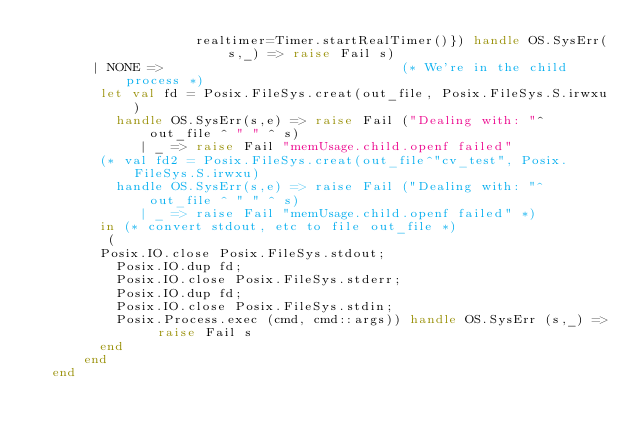<code> <loc_0><loc_0><loc_500><loc_500><_SML_>					realtimer=Timer.startRealTimer()}) handle OS.SysErr(s,_) => raise Fail s)
	   | NONE =>                              (* We're in the child process *)
	    let val fd = Posix.FileSys.creat(out_file, Posix.FileSys.S.irwxu)
	      handle OS.SysErr(s,e) => raise Fail ("Dealing with: "^ out_file ^ " " ^ s)
             | _ => raise Fail "memUsage.child.openf failed"
        (* val fd2 = Posix.FileSys.creat(out_file^"cv_test", Posix.FileSys.S.irwxu)
	      handle OS.SysErr(s,e) => raise Fail ("Dealing with: "^ out_file ^ " " ^ s)
             | _ => raise Fail "memUsage.child.openf failed" *)
	    in (* convert stdout, etc to file out_file *)
	     (
        Posix.IO.close Posix.FileSys.stdout;
	      Posix.IO.dup fd;
	      Posix.IO.close Posix.FileSys.stderr;
	      Posix.IO.dup fd;
	      Posix.IO.close Posix.FileSys.stdin;
	      Posix.Process.exec (cmd, cmd::args)) handle OS.SysErr (s,_) => raise Fail s
	    end
      end
  end

</code> 